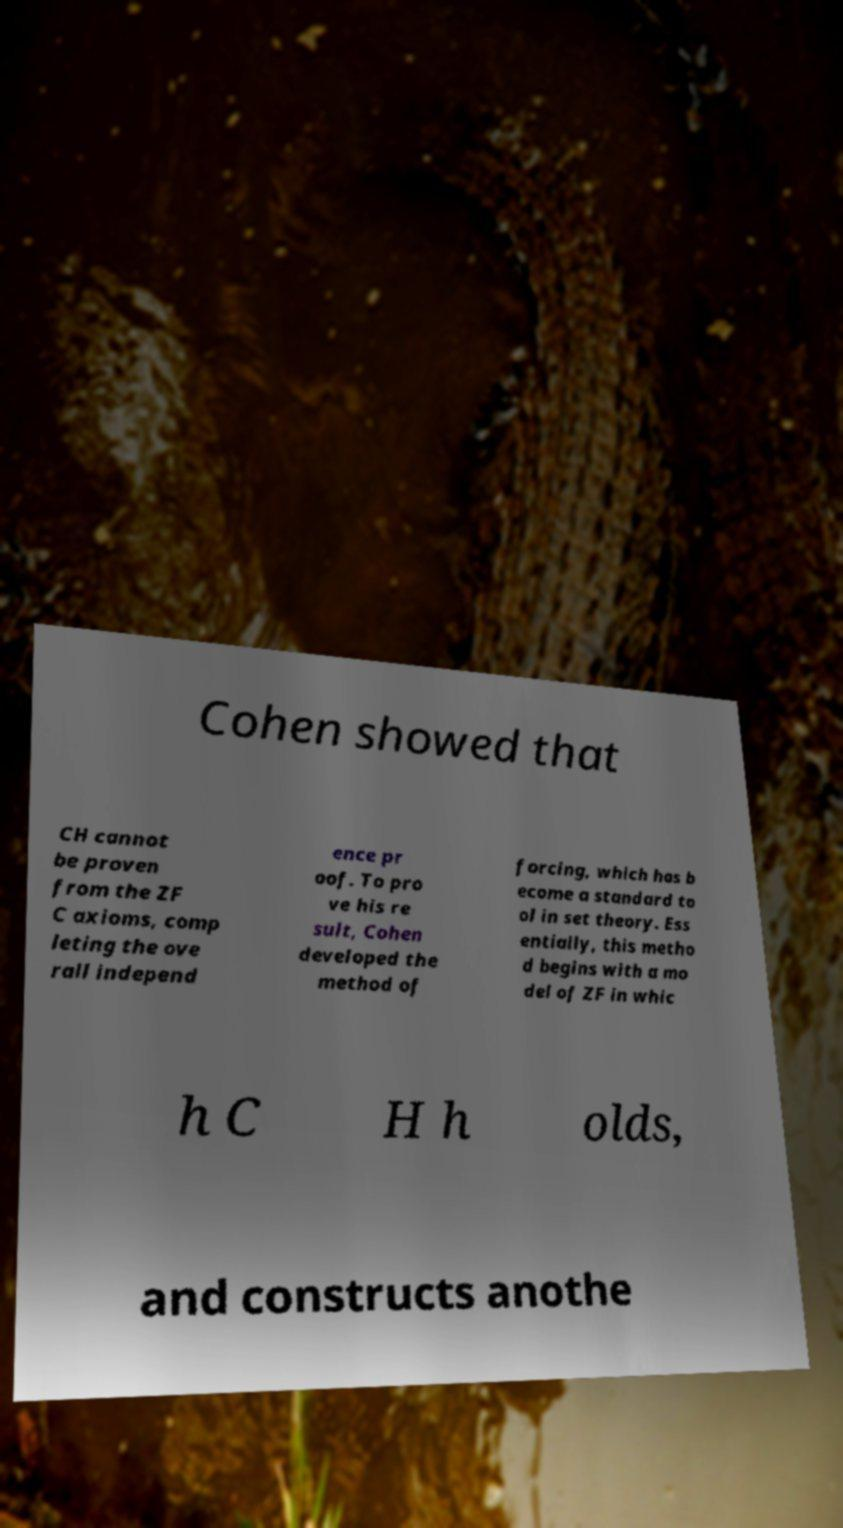There's text embedded in this image that I need extracted. Can you transcribe it verbatim? Cohen showed that CH cannot be proven from the ZF C axioms, comp leting the ove rall independ ence pr oof. To pro ve his re sult, Cohen developed the method of forcing, which has b ecome a standard to ol in set theory. Ess entially, this metho d begins with a mo del of ZF in whic h C H h olds, and constructs anothe 